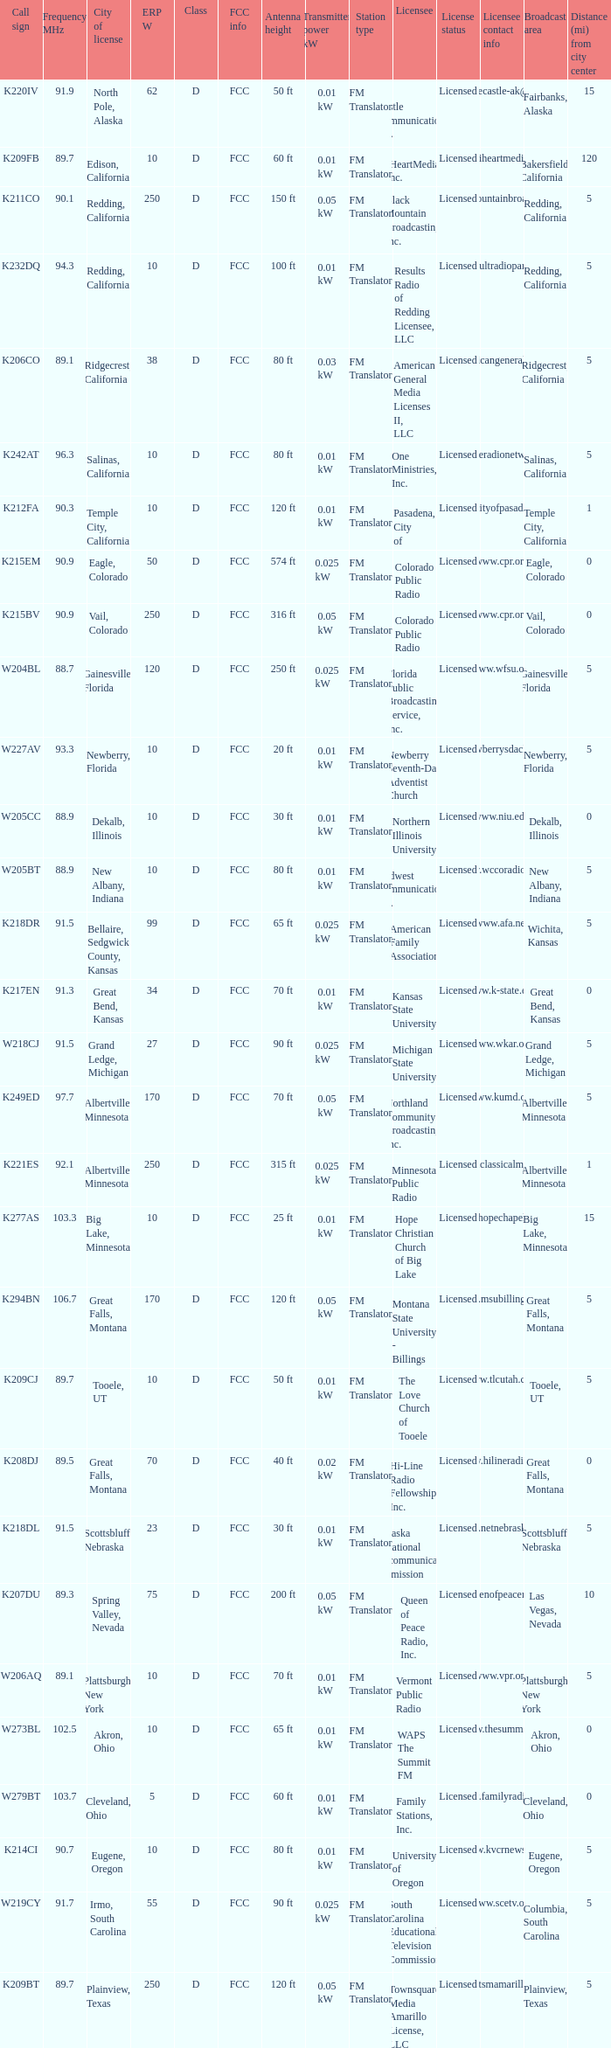What is the FCC info of the translator with an Irmo, South Carolina city license? FCC. 